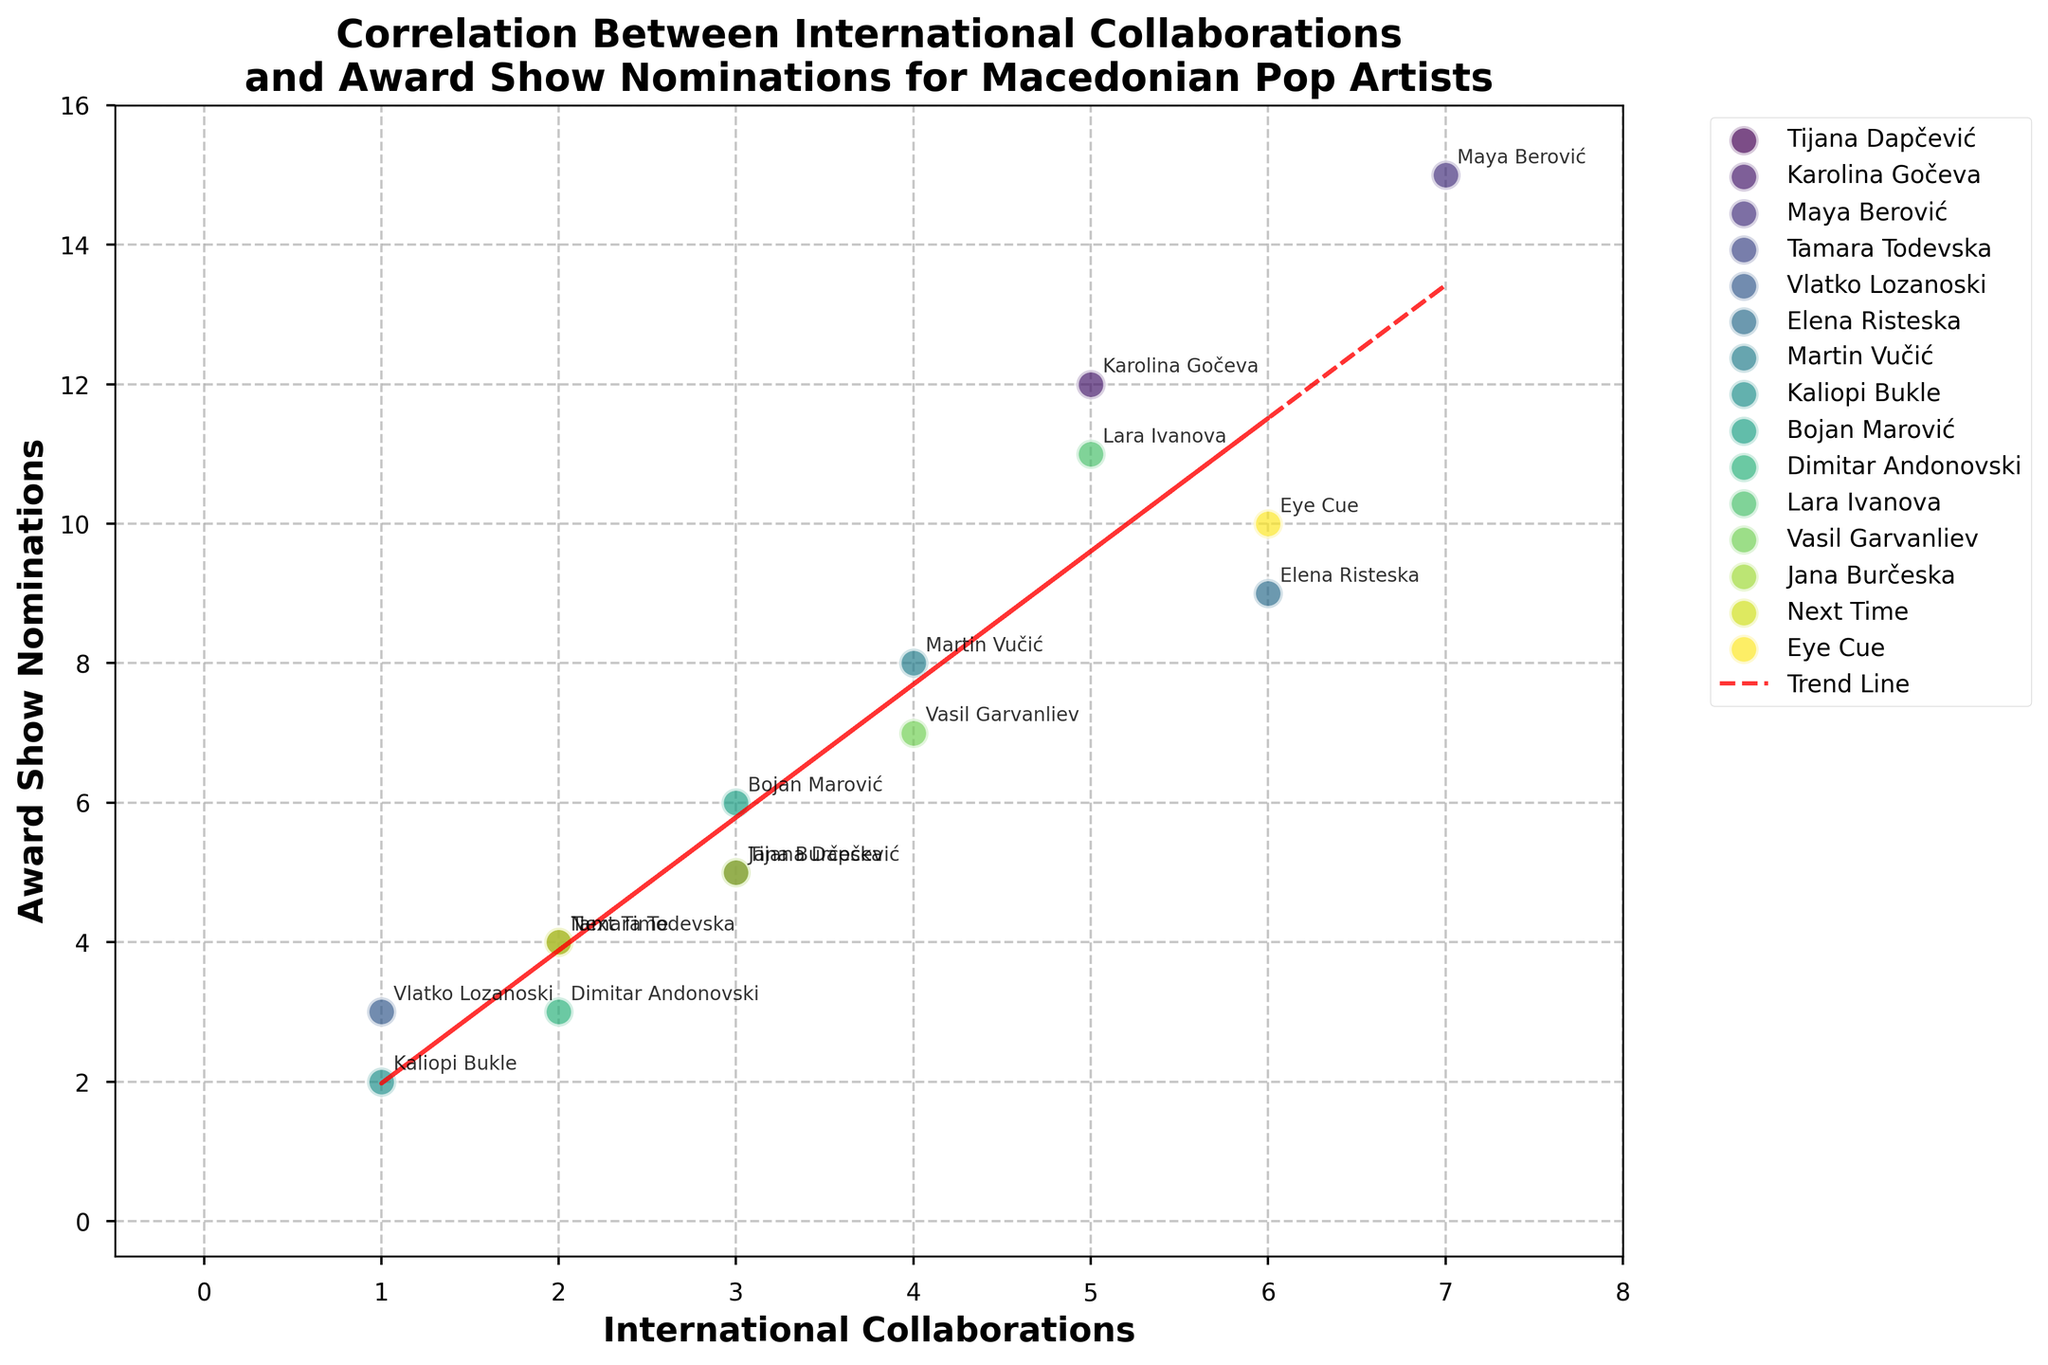What's the title of the plot? The title is usually shown at the top of the figure and is meant to give an overview of what the plot represents.
Answer: Correlation Between International Collaborations and Award Show Nominations for Macedonian Pop Artists How many artists have exactly 3 international collaborations? Count the data points where the x-axis value (International Collaborations) is 3. By looking at the scatter points, you can count them.
Answer: 3 Which artist has the highest number of award show nominations? Find the data point with the highest y-axis value (Award Show Nominations), and identify the artist from the annotations or legend.
Answer: Maya Berović What's the trend shown by the trend line? The trend line indicates the general relationship between the two variables. Look at the slope of the red dashed trend line. If it goes upward from left to right, it shows a positive correlation.
Answer: Positive correlation How many artists have more than 10 award show nominations? Count the data points where the y-axis value (Award Show Nominations) is greater than 10. Compare each point's y-value to 10 and count those that exceed this value.
Answer: 2 Which two artists have the same number of international collaborations but a different number of award show nominations? Look for pairs of data points that have the same x-axis value (International Collaborations) but different y-axis values (Award Show Nominations). Identify the artists from these points.
Answer: Dimitar Andonovski and Tamara Todevska (2 collaborations, different nominations) Who has more award show nominations: Bojan Marović or Jana Burčeska? Compare the y-axis values (Award Show Nominations) for the points labeled Bojan Marović and Jana Burčeska.
Answer: Bojan Marović What is the average number of award show nominations for artists with 6 international collaborations? Identify the points where the x-axis value (International Collaborations) is 6. Sum their y-axis values and divide by the number of such points.
Answer: (9 + 10)/2 = 9.5 Compare the international collaborations of Elena Risteska and Karolina Gočeva. Who has more? Look at the x-axis values (International Collaborations) for the points labeled Elena Risteska and Karolina Gočeva and compare them.
Answer: Karolina Gočeva How does the number of nominations for Kalaopi Bukle compare with the trend line? Look at the y-axis value (Award Show Nominations) for Kalaopi Bukle and compare it with the expected value from the trend line for her number of collaborations. If the point is above the line, she has more nominations than predicted; if below, fewer.
Answer: Below the trend line 